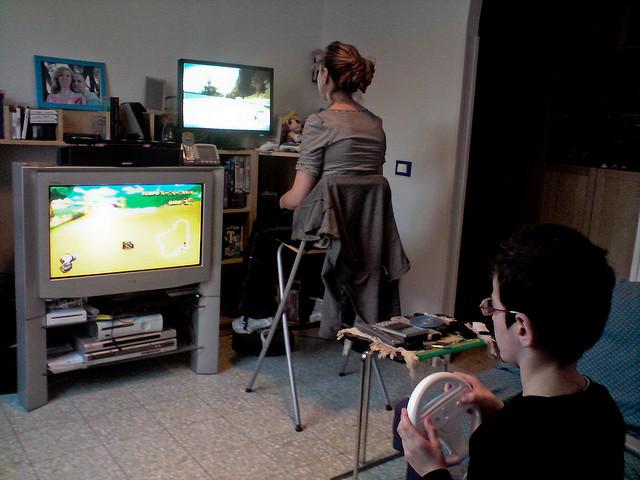How many people are in the room?
Keep it brief. 2. What type of game is the child playing?
Concise answer only. Wii. Is the TV blocking a fireplace?
Short answer required. No. How many people in this shot?
Write a very short answer. 2. What virtual sport are they playing?
Concise answer only. Racing. What type of flooring?
Keep it brief. Tile. Does the boy have spectacles?
Short answer required. Yes. 